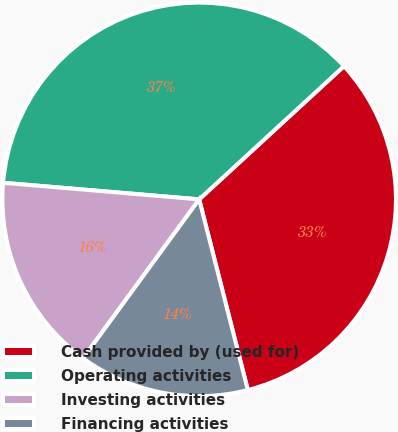Convert chart to OTSL. <chart><loc_0><loc_0><loc_500><loc_500><pie_chart><fcel>Cash provided by (used for)<fcel>Operating activities<fcel>Investing activities<fcel>Financing activities<nl><fcel>32.86%<fcel>36.82%<fcel>16.3%<fcel>14.02%<nl></chart> 